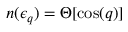Convert formula to latex. <formula><loc_0><loc_0><loc_500><loc_500>n ( \epsilon _ { q } ) = \Theta [ \cos ( q ) ]</formula> 